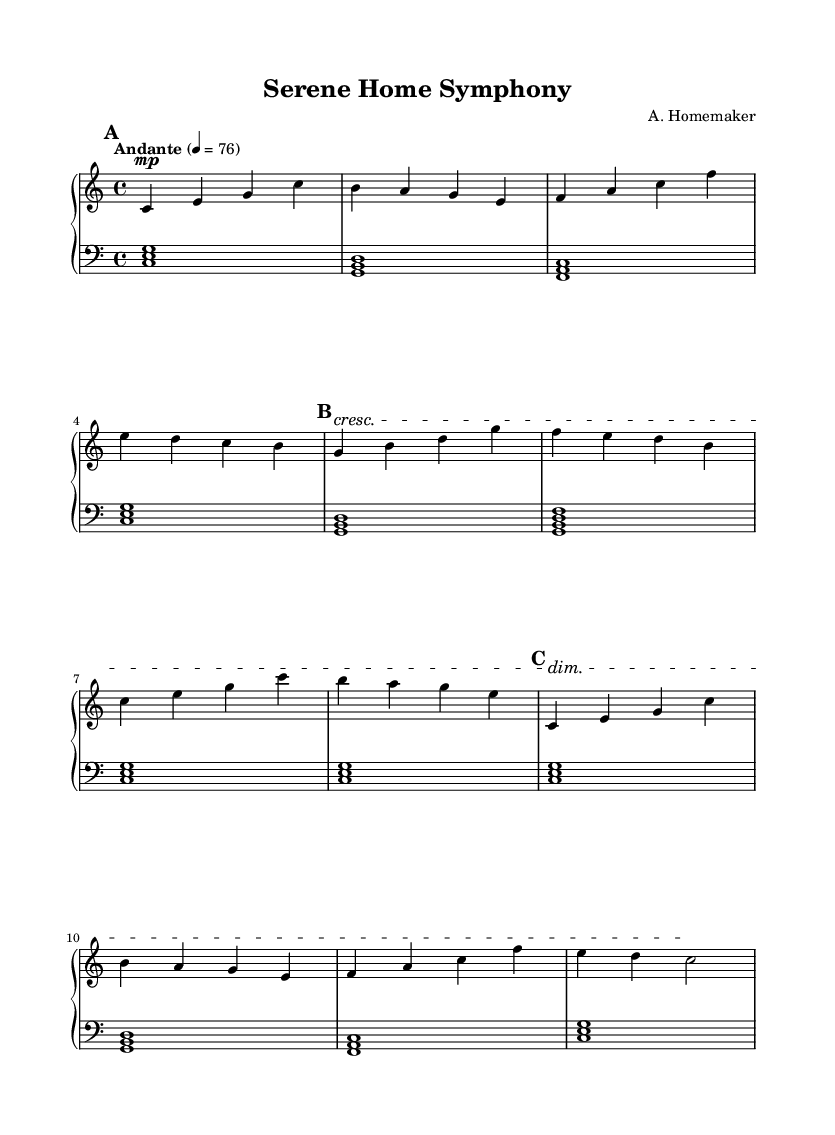What is the key signature of this music? The music is in C major, which is indicated by the absence of sharps or flats in the key signature.
Answer: C major What is the time signature of this piece? The time signature is found at the beginning of the score, represented as 4/4, which means four beats in a measure and a quarter note gets one beat.
Answer: 4/4 What is the tempo marking of the piece? The tempo is marked as "Andante" with a metronome marking of 76, suggesting a moderate walking pace.
Answer: Andante 76 How many sections are there in the music? By analyzing the structure in the score, the music has three sections labeled A, B, and A', indicating there are three distinct parts.
Answer: Three What is the dynamic marking at the beginning of section B? The dynamic marking increases to a crescendo, which is indicated by the symbol in the score, meaning to gradually get louder.
Answer: Crescendo What type of instrument is indicated in the score? The score specifies "acoustic grand" as the midiInstrument, showing that the piece is arranged for piano, particularly an acoustic grand piano.
Answer: Acoustic grand What is the final dynamic marking at the end of section A'? At the end of section A', the dynamic marking is a dim, indicating that the music should gradually decrease in volume.
Answer: Diminuendo 